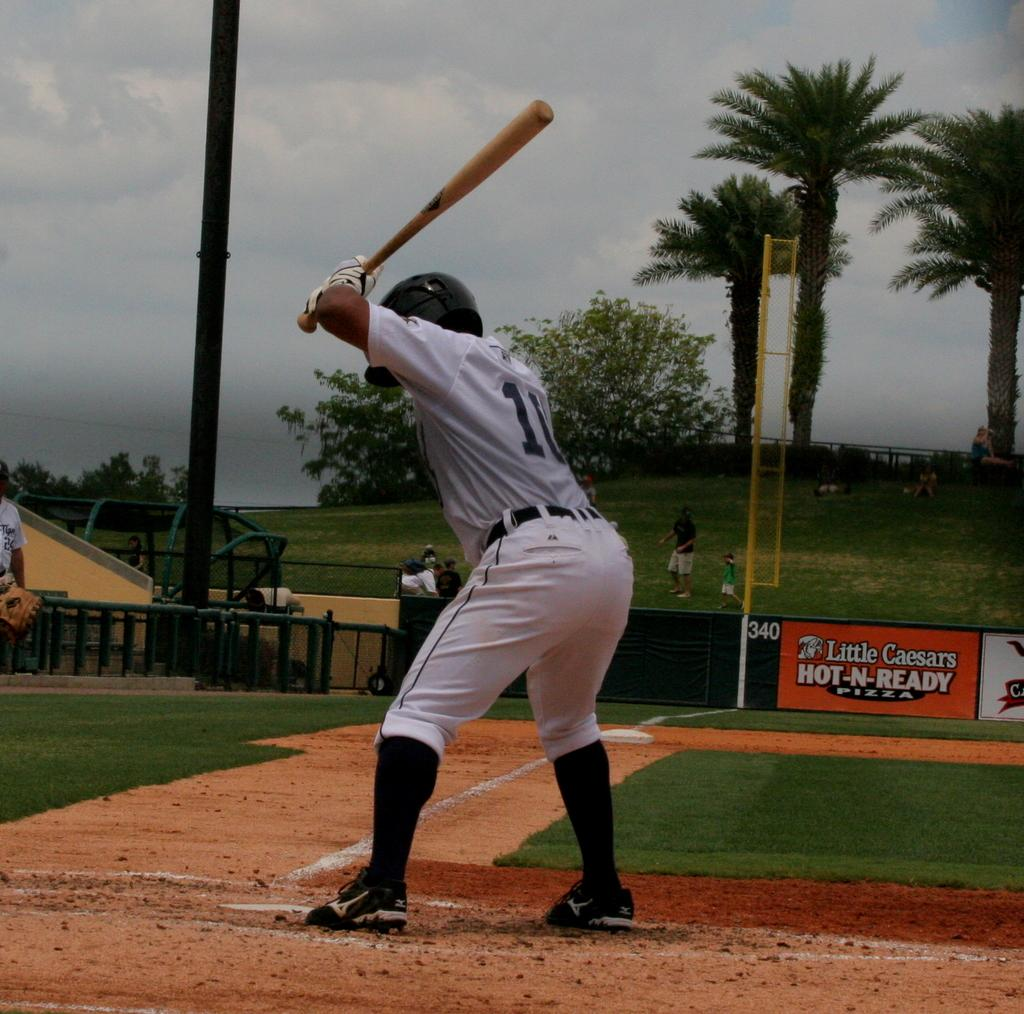<image>
Offer a succinct explanation of the picture presented. At this baseball pitch, Little Caesars Pizzas are advertised. 